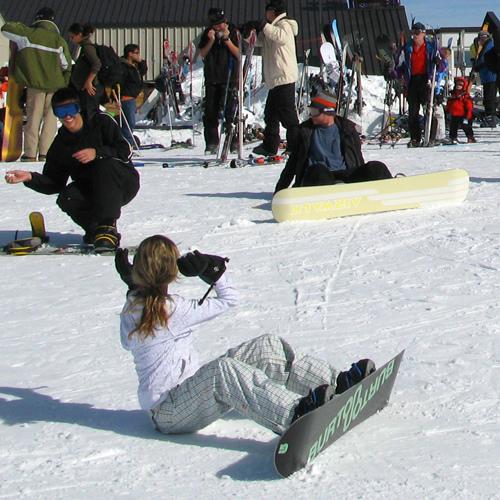Is the girl skiing?
Short answer required. No. Is this girl sitting?
Concise answer only. Yes. How many snowboarders are sitting?
Keep it brief. 2. 